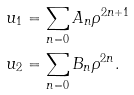Convert formula to latex. <formula><loc_0><loc_0><loc_500><loc_500>u _ { 1 } & = \sum _ { n = 0 } A _ { n } \rho ^ { 2 n + 1 } \\ u _ { 2 } & = \sum _ { n = 0 } B _ { n } \rho ^ { 2 n } .</formula> 